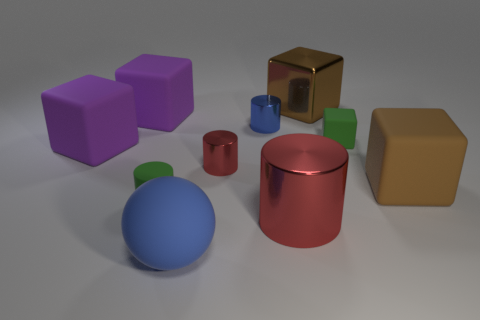How many other small green cylinders are made of the same material as the small green cylinder?
Provide a short and direct response. 0. Does the rubber block that is behind the green rubber cube have the same size as the blue thing behind the big blue thing?
Give a very brief answer. No. What material is the big brown block that is on the left side of the large brown object in front of the brown metallic thing?
Give a very brief answer. Metal. Are there fewer tiny objects on the left side of the big sphere than brown shiny blocks to the left of the blue shiny thing?
Your response must be concise. No. There is a small thing that is the same color as the big cylinder; what material is it?
Your answer should be compact. Metal. Is there any other thing that is the same shape as the tiny red object?
Your response must be concise. Yes. What material is the tiny red object that is to the left of the big brown shiny thing?
Provide a short and direct response. Metal. Are there any other things that are the same size as the rubber cylinder?
Provide a succinct answer. Yes. Are there any green cylinders in front of the big shiny cylinder?
Offer a very short reply. No. What shape is the large blue object?
Make the answer very short. Sphere. 